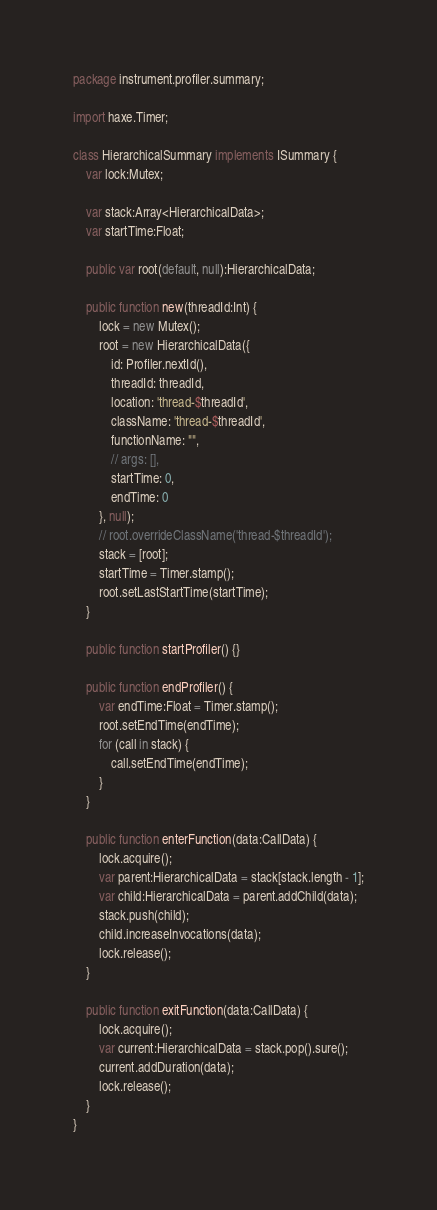<code> <loc_0><loc_0><loc_500><loc_500><_Haxe_>package instrument.profiler.summary;

import haxe.Timer;

class HierarchicalSummary implements ISummary {
	var lock:Mutex;

	var stack:Array<HierarchicalData>;
	var startTime:Float;

	public var root(default, null):HierarchicalData;

	public function new(threadId:Int) {
		lock = new Mutex();
		root = new HierarchicalData({
			id: Profiler.nextId(),
			threadId: threadId,
			location: 'thread-$threadId',
			className: 'thread-$threadId',
			functionName: "",
			// args: [],
			startTime: 0,
			endTime: 0
		}, null);
		// root.overrideClassName('thread-$threadId');
		stack = [root];
		startTime = Timer.stamp();
		root.setLastStartTime(startTime);
	}

	public function startProfiler() {}

	public function endProfiler() {
		var endTime:Float = Timer.stamp();
		root.setEndTime(endTime);
		for (call in stack) {
			call.setEndTime(endTime);
		}
	}

	public function enterFunction(data:CallData) {
		lock.acquire();
		var parent:HierarchicalData = stack[stack.length - 1];
		var child:HierarchicalData = parent.addChild(data);
		stack.push(child);
		child.increaseInvocations(data);
		lock.release();
	}

	public function exitFunction(data:CallData) {
		lock.acquire();
		var current:HierarchicalData = stack.pop().sure();
		current.addDuration(data);
		lock.release();
	}
}
</code> 